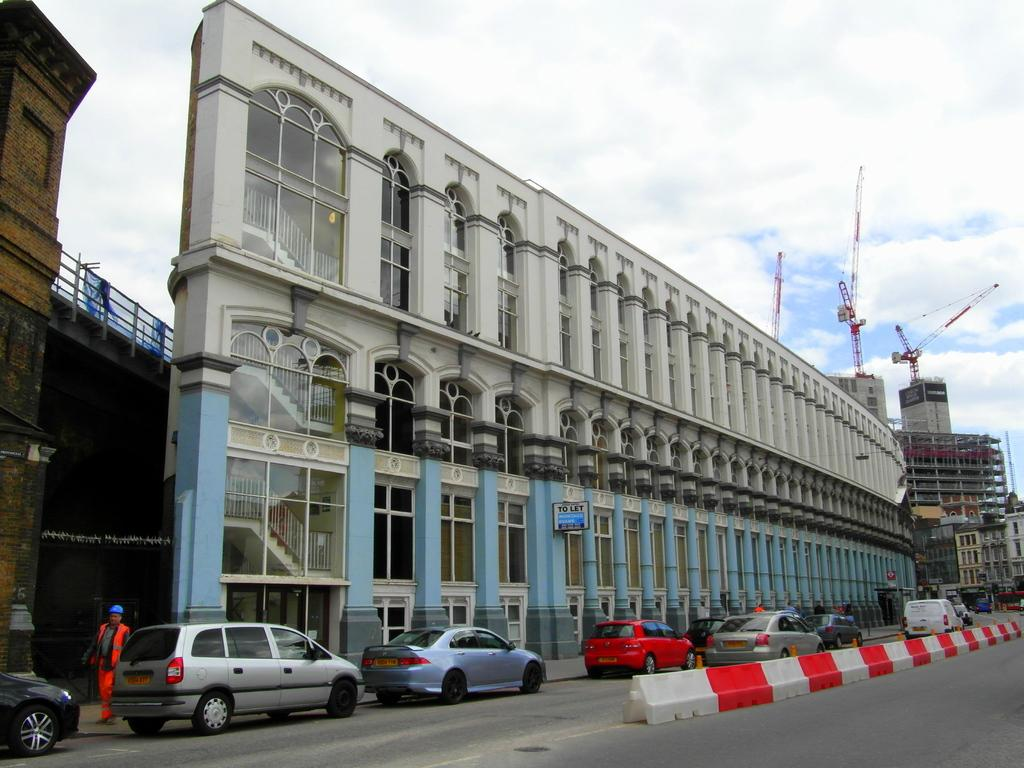What type of vehicles can be seen on the road in the image? There are cars on the road in the image. What are the people in the image doing? The people in the image are standing. What can be seen in the background of the image? There are buildings visible in the background of the image. What is visible at the top of the image? The sky is visible at the top of the image. What type of reward is being given to the robin in the image? There is no robin present in the image, so no reward can be given to a robin. What is the weight of the cars on the road in the image? The weight of the cars cannot be determined from the image alone, as it does not provide information about the specific make, model, or size of the vehicles. 